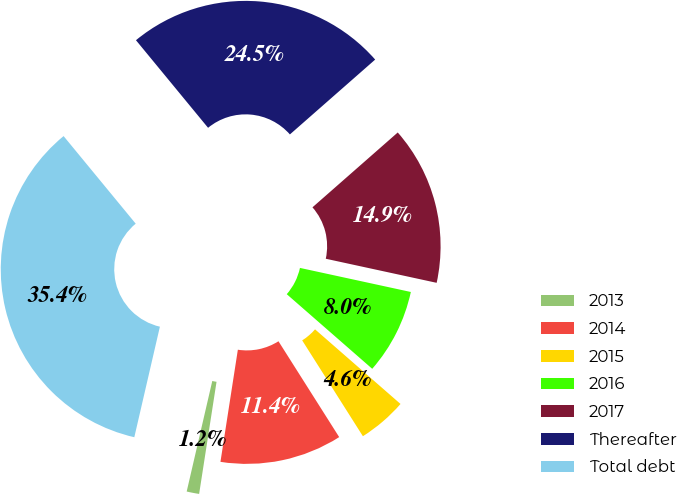<chart> <loc_0><loc_0><loc_500><loc_500><pie_chart><fcel>2013<fcel>2014<fcel>2015<fcel>2016<fcel>2017<fcel>Thereafter<fcel>Total debt<nl><fcel>1.17%<fcel>11.44%<fcel>4.59%<fcel>8.02%<fcel>14.87%<fcel>24.5%<fcel>35.42%<nl></chart> 